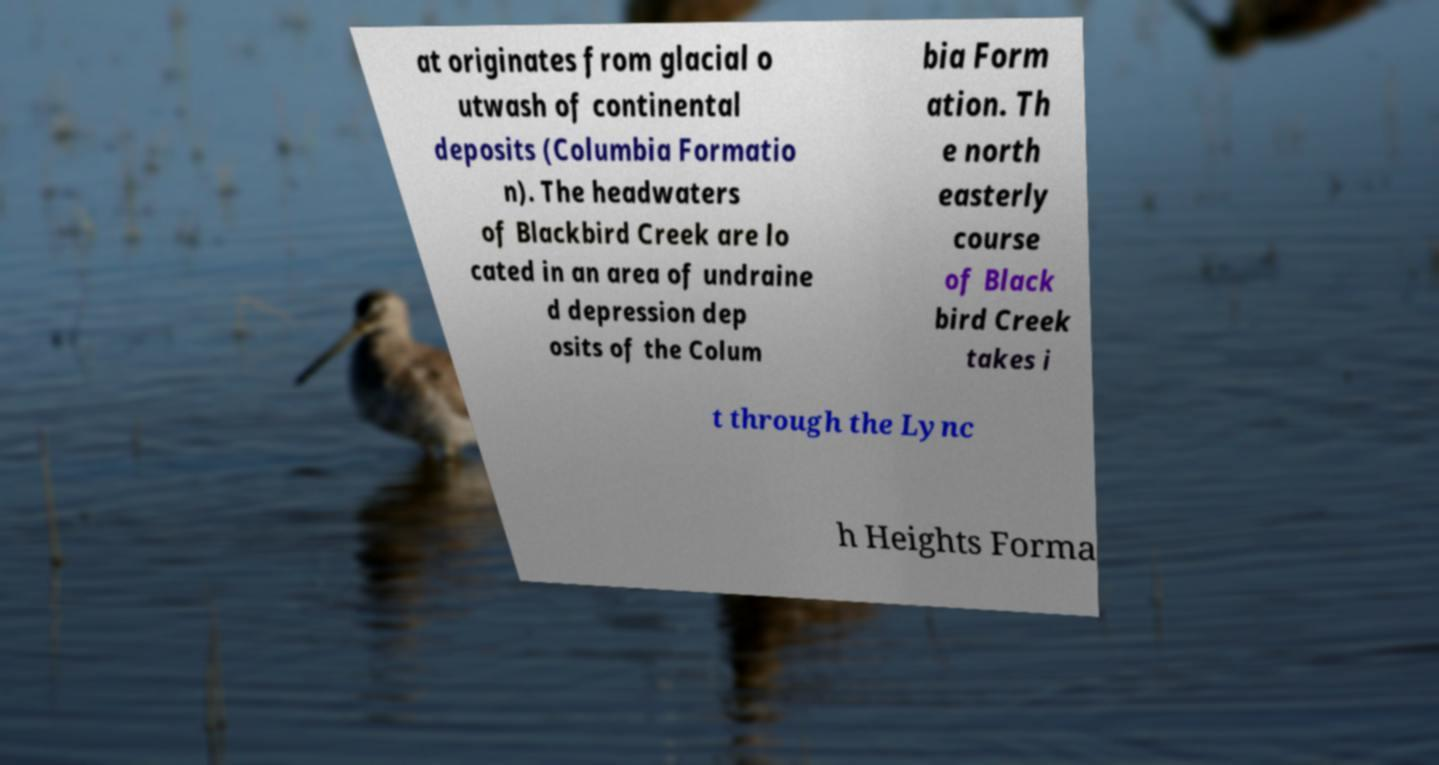Could you assist in decoding the text presented in this image and type it out clearly? at originates from glacial o utwash of continental deposits (Columbia Formatio n). The headwaters of Blackbird Creek are lo cated in an area of undraine d depression dep osits of the Colum bia Form ation. Th e north easterly course of Black bird Creek takes i t through the Lync h Heights Forma 